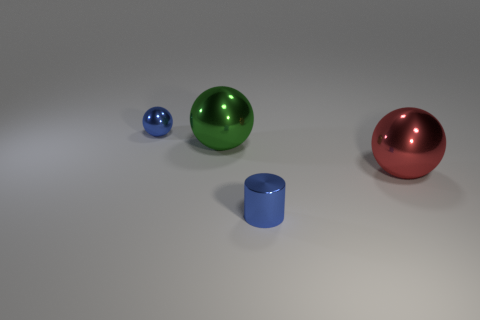Are there the same number of big red things that are in front of the blue shiny cylinder and shiny balls right of the green ball?
Offer a very short reply. No. How many other objects are the same shape as the large green thing?
Your answer should be compact. 2. Do the object to the right of the cylinder and the blue shiny thing that is in front of the green shiny object have the same size?
Make the answer very short. No. What number of spheres are large objects or red things?
Your response must be concise. 2. What number of metal things are blue spheres or small green cubes?
Your response must be concise. 1. There is a blue thing that is the same shape as the red metallic object; what size is it?
Your answer should be compact. Small. Are there any other things that are the same size as the blue shiny cylinder?
Provide a succinct answer. Yes. There is a green thing; is it the same size as the metal sphere on the right side of the small blue shiny cylinder?
Your answer should be very brief. Yes. What shape is the tiny metallic object in front of the small blue sphere?
Provide a short and direct response. Cylinder. What is the color of the large ball left of the tiny thing in front of the large red shiny sphere?
Keep it short and to the point. Green. 